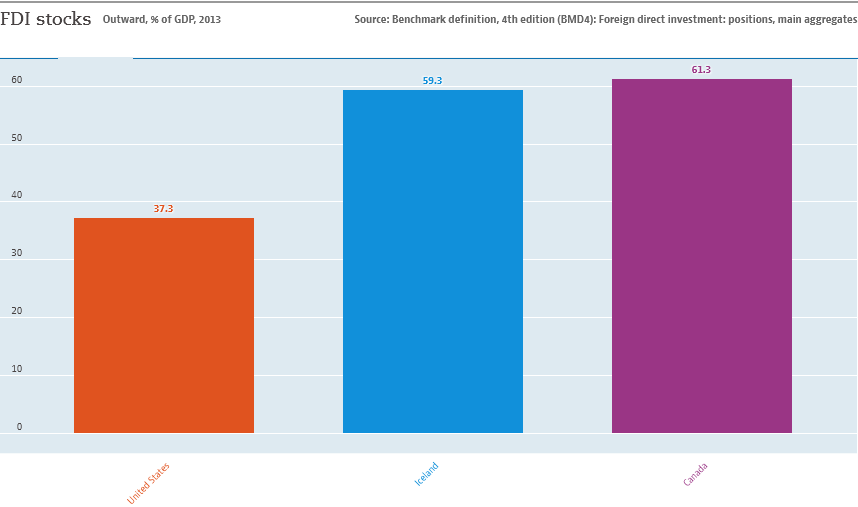What is the value of the highest bar? The highest value on the bar chart, representing Foreign Direct Investment (FDI) stocks as a percentage of GDP for the year 2013, is shown by the bar for Canada, which stands at 61.3%. 